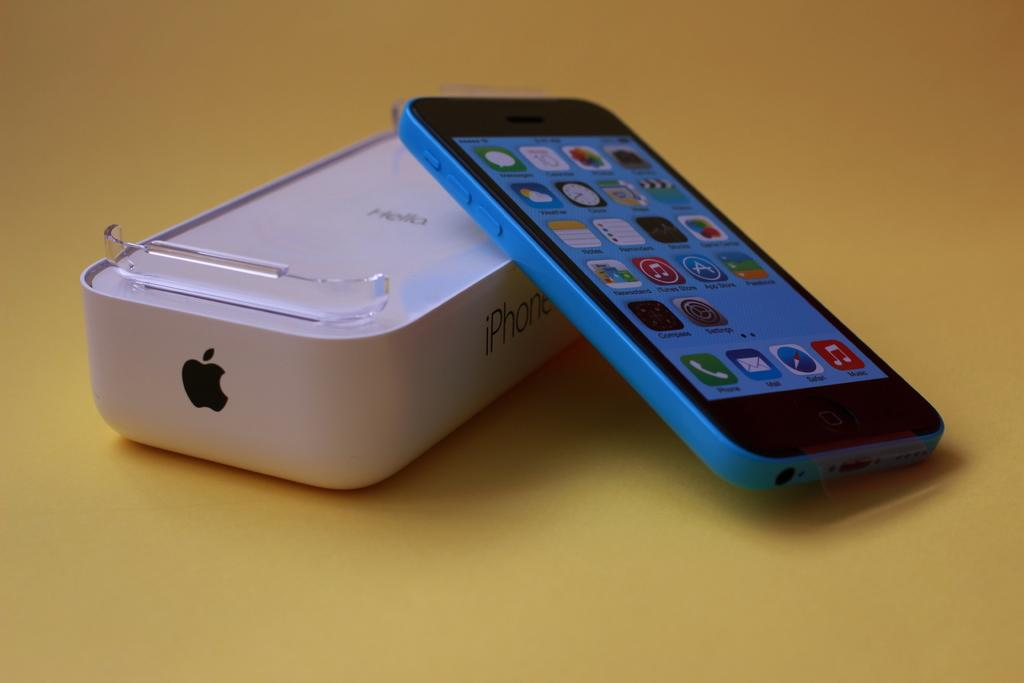<image>
Offer a succinct explanation of the picture presented. A blue Apple Iphone has many icons on its screen, including Notes, Phone, and Mail and sits next to its case. 